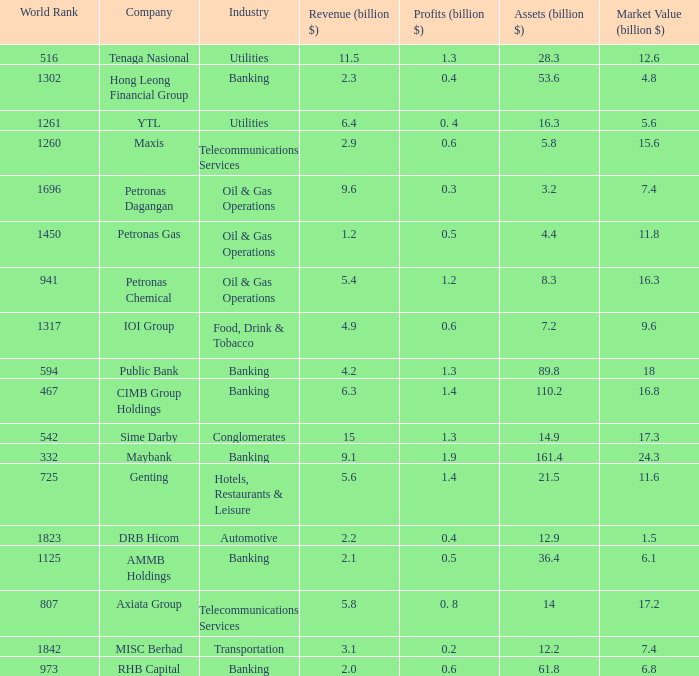Name the total number of industry for maxis 1.0. 